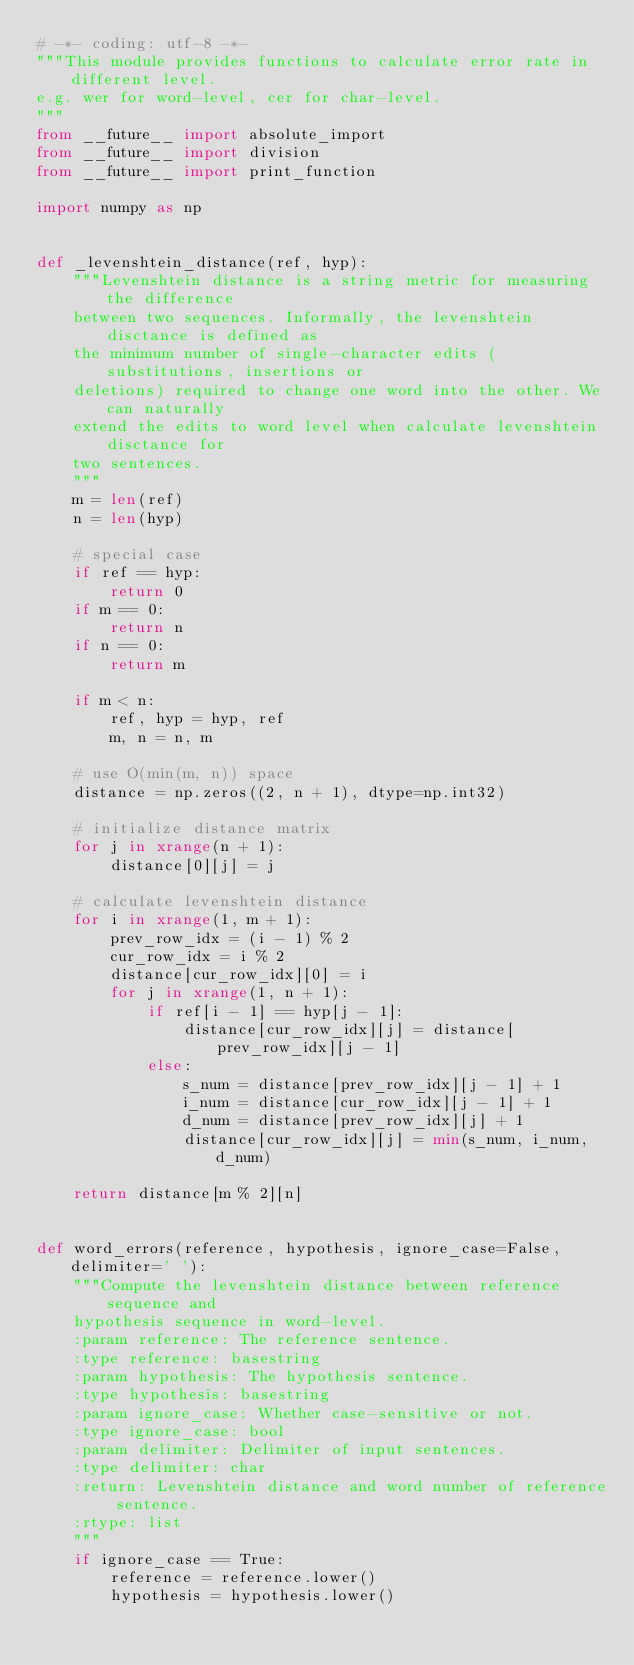Convert code to text. <code><loc_0><loc_0><loc_500><loc_500><_Python_># -*- coding: utf-8 -*-
"""This module provides functions to calculate error rate in different level.
e.g. wer for word-level, cer for char-level.
"""
from __future__ import absolute_import
from __future__ import division
from __future__ import print_function

import numpy as np


def _levenshtein_distance(ref, hyp):
    """Levenshtein distance is a string metric for measuring the difference
    between two sequences. Informally, the levenshtein disctance is defined as
    the minimum number of single-character edits (substitutions, insertions or
    deletions) required to change one word into the other. We can naturally
    extend the edits to word level when calculate levenshtein disctance for
    two sentences.
    """
    m = len(ref)
    n = len(hyp)

    # special case
    if ref == hyp:
        return 0
    if m == 0:
        return n
    if n == 0:
        return m

    if m < n:
        ref, hyp = hyp, ref
        m, n = n, m

    # use O(min(m, n)) space
    distance = np.zeros((2, n + 1), dtype=np.int32)

    # initialize distance matrix
    for j in xrange(n + 1):
        distance[0][j] = j

    # calculate levenshtein distance
    for i in xrange(1, m + 1):
        prev_row_idx = (i - 1) % 2
        cur_row_idx = i % 2
        distance[cur_row_idx][0] = i
        for j in xrange(1, n + 1):
            if ref[i - 1] == hyp[j - 1]:
                distance[cur_row_idx][j] = distance[prev_row_idx][j - 1]
            else:
                s_num = distance[prev_row_idx][j - 1] + 1
                i_num = distance[cur_row_idx][j - 1] + 1
                d_num = distance[prev_row_idx][j] + 1
                distance[cur_row_idx][j] = min(s_num, i_num, d_num)

    return distance[m % 2][n]


def word_errors(reference, hypothesis, ignore_case=False, delimiter=' '):
    """Compute the levenshtein distance between reference sequence and
    hypothesis sequence in word-level.
    :param reference: The reference sentence.
    :type reference: basestring
    :param hypothesis: The hypothesis sentence.
    :type hypothesis: basestring
    :param ignore_case: Whether case-sensitive or not.
    :type ignore_case: bool
    :param delimiter: Delimiter of input sentences.
    :type delimiter: char
    :return: Levenshtein distance and word number of reference sentence.
    :rtype: list
    """
    if ignore_case == True:
        reference = reference.lower()
        hypothesis = hypothesis.lower()
</code> 